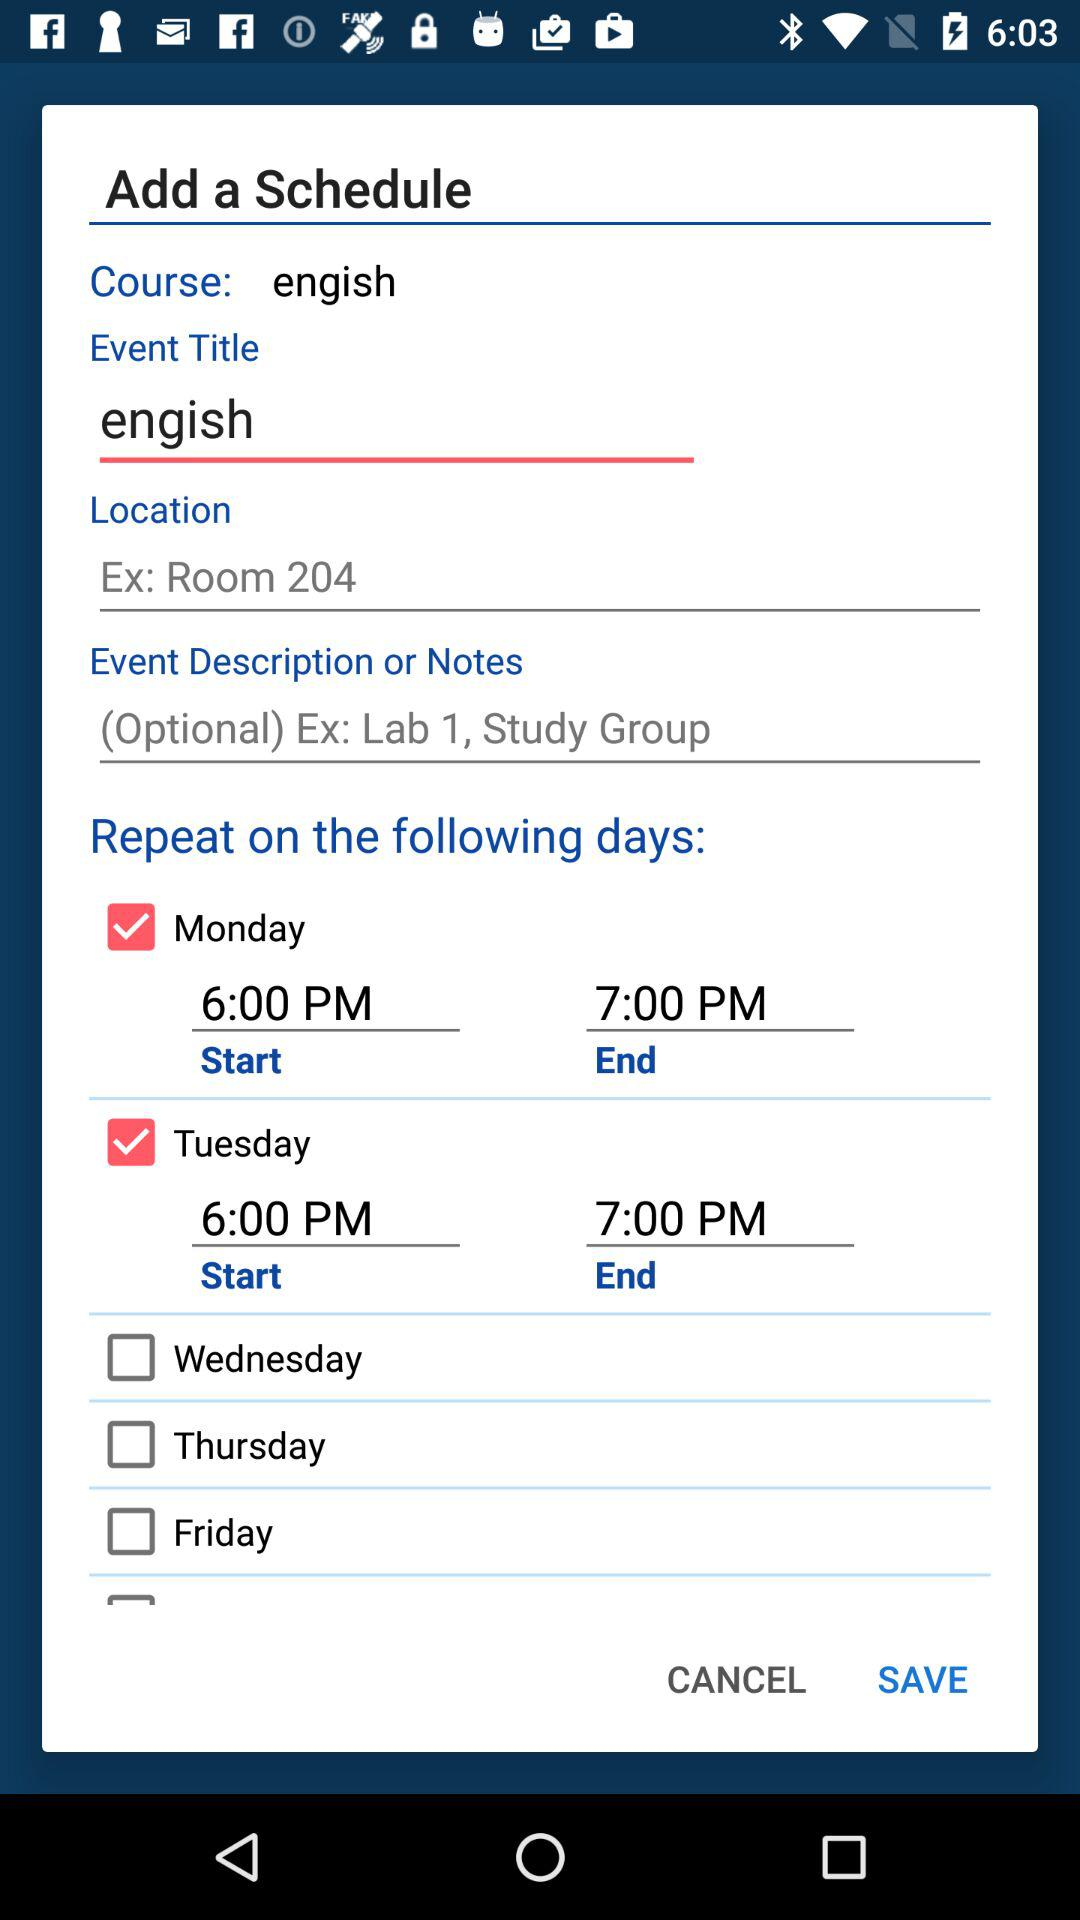What is the scheduled start time for Monday? The scheduled start time for Monday is 6:00 PM. 